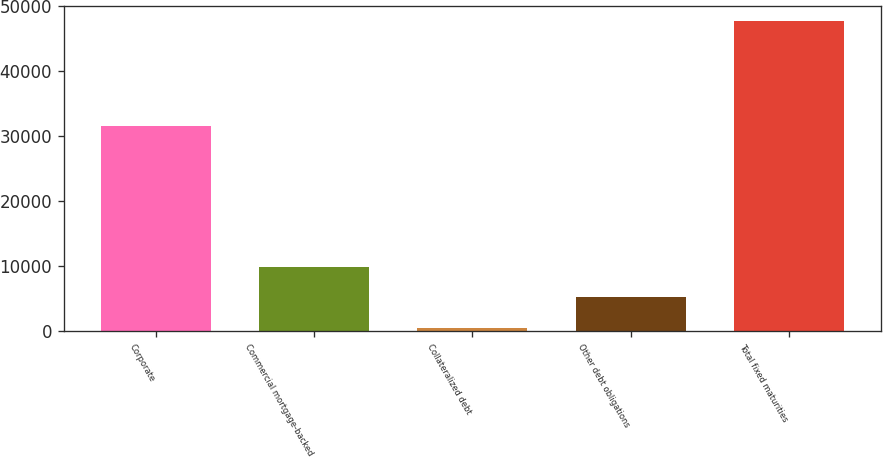Convert chart. <chart><loc_0><loc_0><loc_500><loc_500><bar_chart><fcel>Corporate<fcel>Commercial mortgage-backed<fcel>Collateralized debt<fcel>Other debt obligations<fcel>Total fixed maturities<nl><fcel>31615.4<fcel>9886.1<fcel>428.8<fcel>5157.45<fcel>47715.3<nl></chart> 